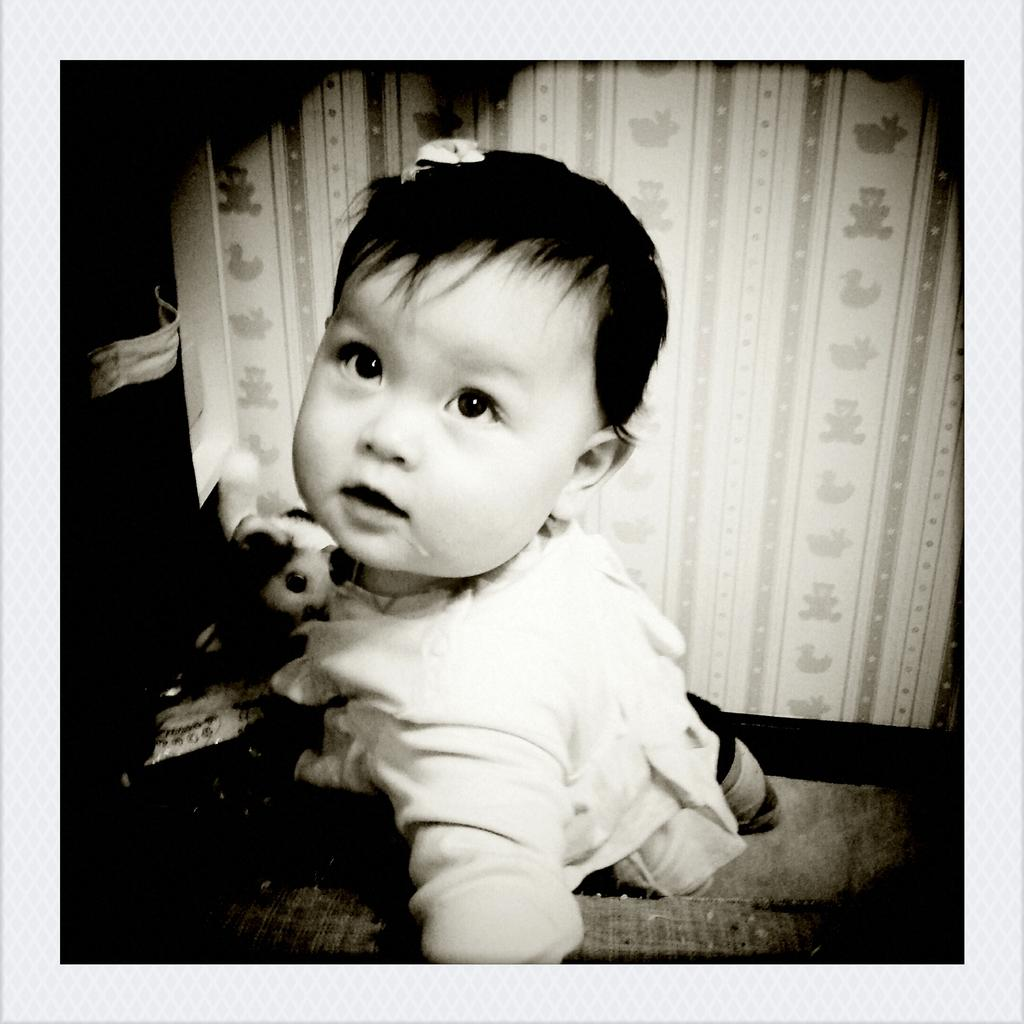What is the main subject of the image? There is a baby in the image. What is the baby wearing? The baby is wearing clothes. Can you describe the lighting in the image? The corners of the image are dark. Is there a stream visible in the image? No, there is no stream present in the image. What type of authority figure can be seen in the image? There is no authority figure present in the image; it features a baby. 